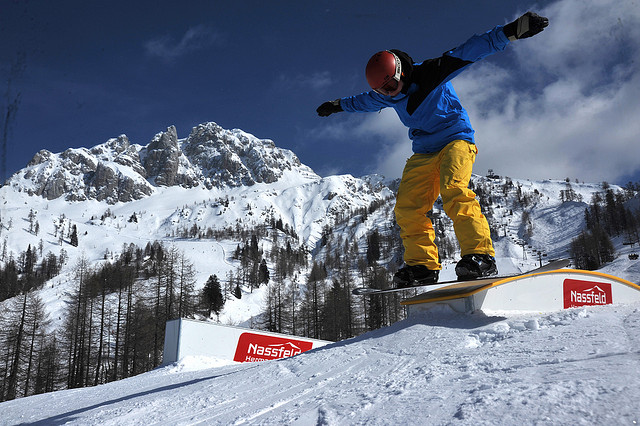What might the snowboarder be thinking as they perform this trick? As the snowboarder performs this trick, their mind is likely a focused blend of concentration and exhilaration. They're intensely aware of their body's movements, the balance on the rail, and the coordination required to land perfectly. Beyond this sharp focus, there’s a surge of adrenaline and a feeling of freedom that comes with defying gravity and mastering the mountain. They might also be reflecting on the practice and effort it took to reach this moment or feeling a rush of joy and accomplishment in the midst of this high-stakes performance. 